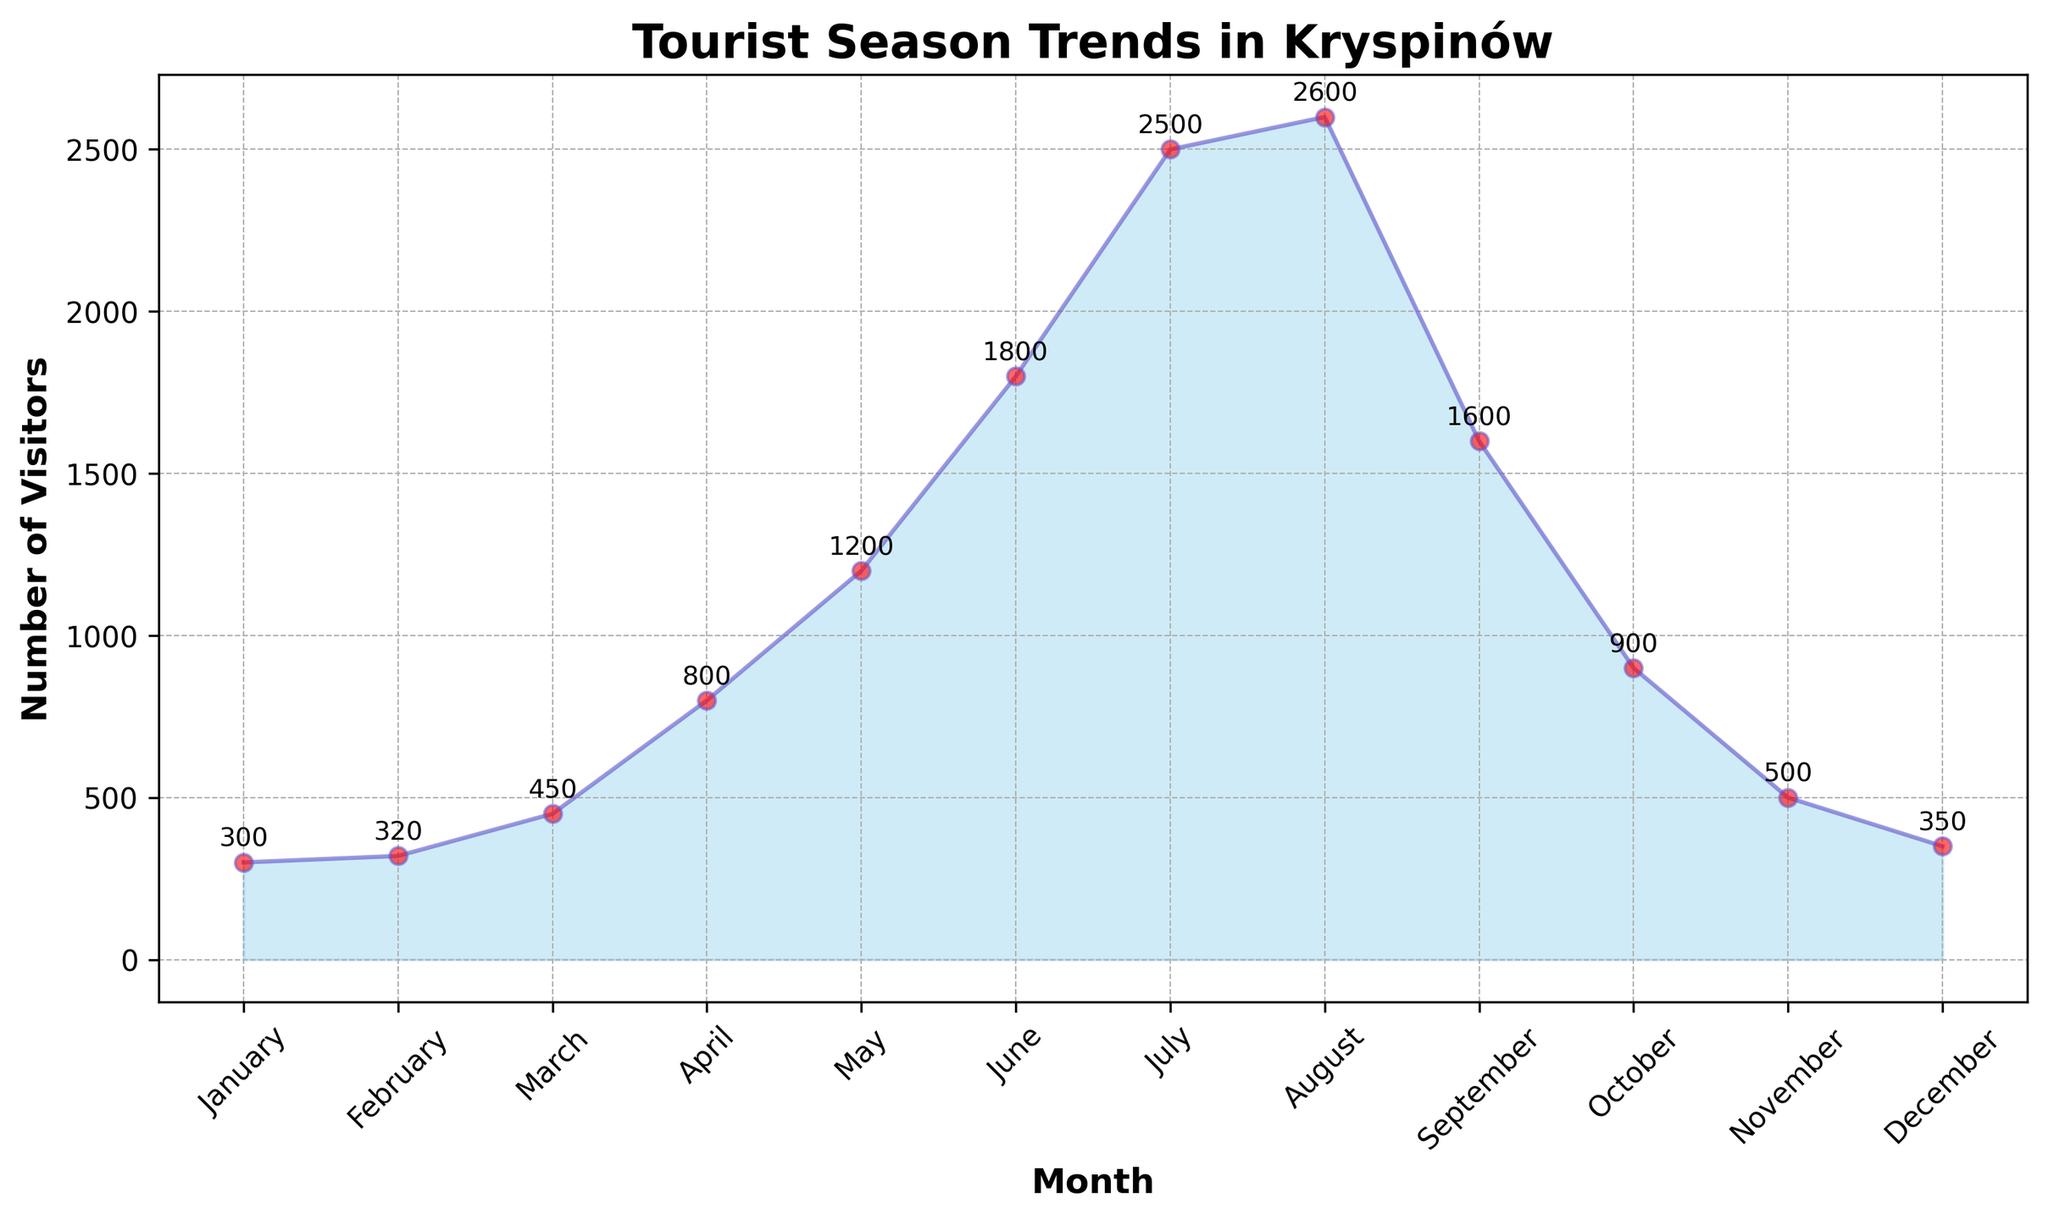Which month has the fewest visitors? Look at the graph and find the lowest point on the area chart, which represents the month with the fewest visitors. The lowest point corresponds to January.
Answer: January How many more visitors were there in July compared to January? Find the number of visitors in July (2500) and January (300). Subtract the number of visitors in January from the number of visitors in July: 2500 - 300 = 2200.
Answer: 2200 Which two consecutive months show the biggest increase in the number of visitors? Look for the steepest upward slope on the graph, indicating the largest increase between two consecutive months. The steepest rise is from June (1800) to July (2500), an increase of 700.
Answer: June to July What is the average number of visitors per month from January to December? Add up the total number of visitors from all months, then divide by 12 (the number of months). Total visitors = 300 + 320 + 450 + 800 + 1200 + 1800 + 2500 + 2600 + 1600 + 900 + 500 + 350 = 14320. Average = 14320 / 12 ≈ 1193.33.
Answer: Approximately 1193 Which month has just slightly fewer visitors than the peak month, and how many visitors does it have? Identify the peak month, which is August with 2600 visitors. The month with slightly fewer visitors than August is July, which has 2500 visitors.
Answer: July with 2500 visitors How much more popular is the tourist season in the summer (June to August) compared to the winter (December to February)? Calculate the total visitors during the summer (June to August): 1800 + 2500 + 2600 = 6900. Calculate the total visitors during the winter (December to February): 350 + 300 + 320 = 970. Subtract the winter total from the summer total: 6900 - 970 = 5930.
Answer: 5930 What is the percentage increase in visitors from March to April? Calculate the number of visitors in March (450) and April (800). Find the difference, then divide by the number of visitors in March, and multiply by 100: (800 - 450) / 450 * 100 ≈ 77.78%.
Answer: Approximately 77.78% Which month has visitors closest to the yearly average number of visitors, and how many visitors does it have? First, identify the average number of visitors per month (approximately 1193). Then, find the month with visitors closest to this average. October has 900 visitors, which is closest to 1193.
Answer: October with 900 visitors In which months do the visitors count drop compared to the previous month? Identify months where the visitor count decreases compared to the previous month by inspecting the downward slopes: September (1600 to 900 in October), October (900 to 500 in November), and November (500 to 350 in December).
Answer: October, November, December What is the total number of visitors from May to September? Add the number of visitors from May (1200), June (1800), July (2500), August (2600), and September (1600). May to September total = 1200 + 1800 + 2500 + 2600 + 1600 = 9700.
Answer: 9700 